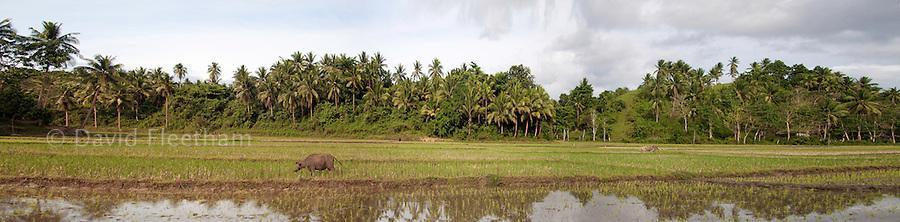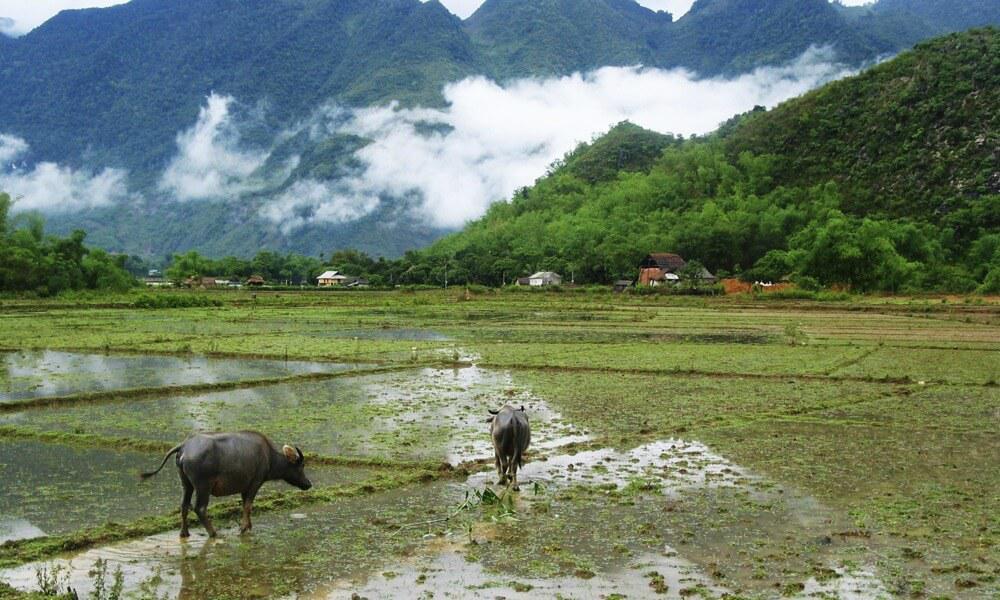The first image is the image on the left, the second image is the image on the right. For the images displayed, is the sentence "The right image features at least one leftward-headed water buffalo standing in profile in water that reaches its belly." factually correct? Answer yes or no. No. The first image is the image on the left, the second image is the image on the right. Given the left and right images, does the statement "The left and right image contains the same number black bulls." hold true? Answer yes or no. No. 